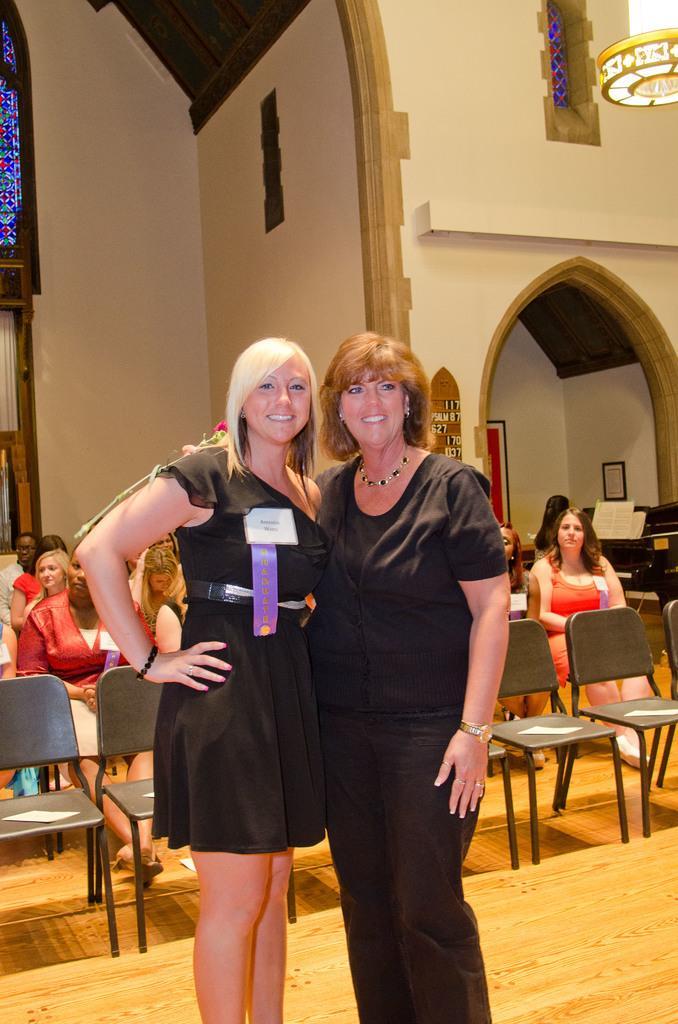How would you summarize this image in a sentence or two? In this picture there are two ladies in black dress and behind them there are some chairs and some people sitting on the chairs. 